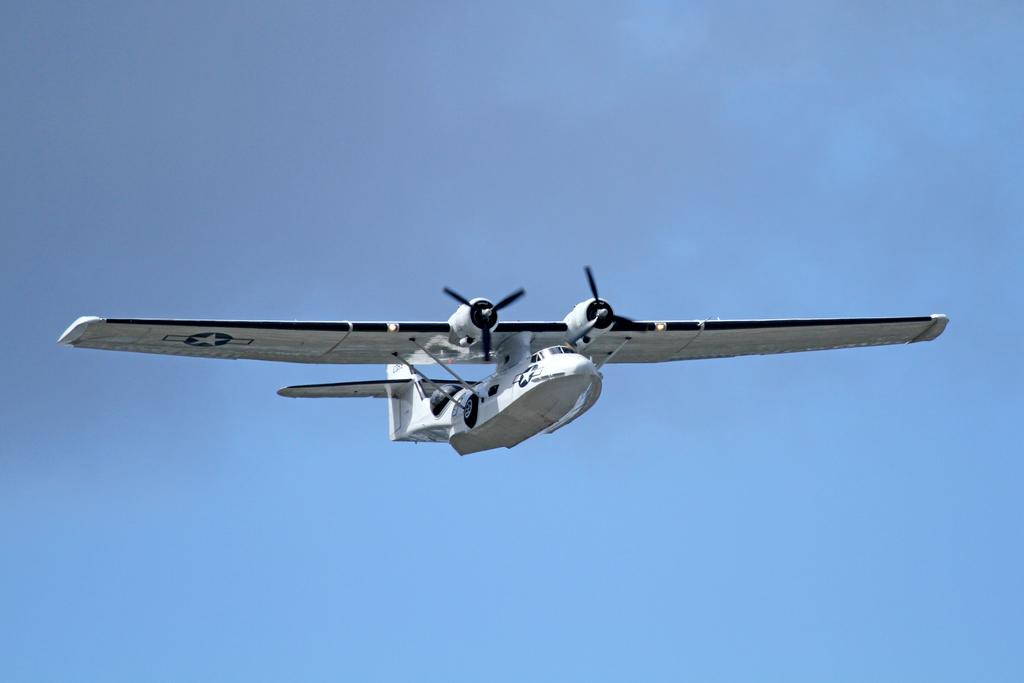What is the main subject of the image? The main subject of the image is an aircraft. What can be seen in the background of the image? The sky is visible in the image. What type of rat can be seen causing damage to the aircraft in the image? There is no rat present in the image, and the aircraft appears to be undamaged. What vein is visible in the image? There are no veins visible in the image, as it features an aircraft and the sky. 